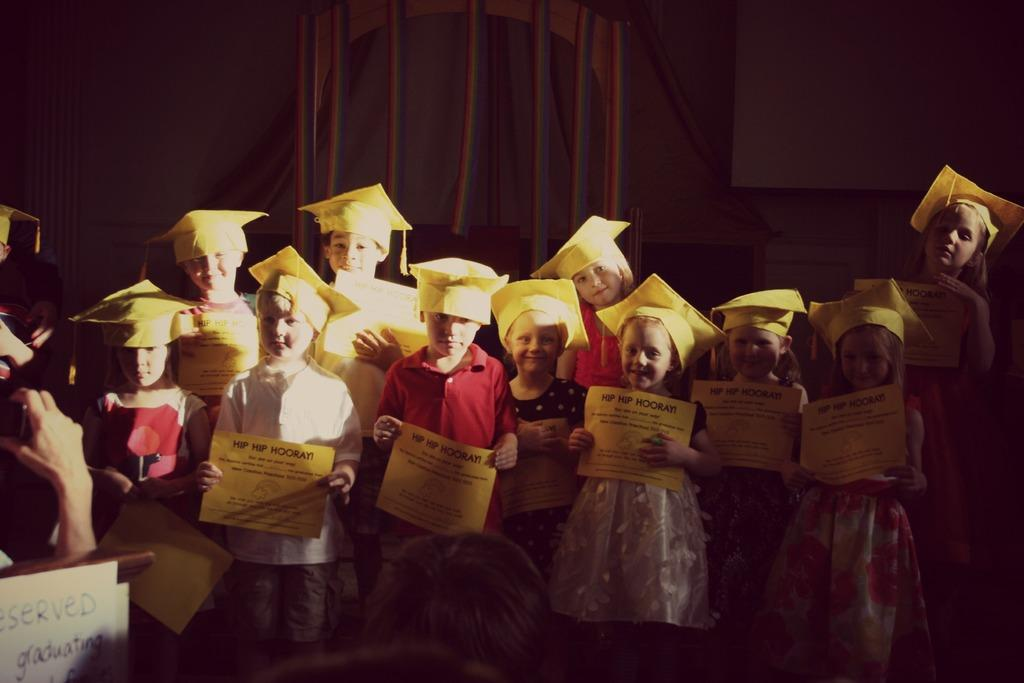What is the main subject of the image? The main subject of the image is a group of children. What are the children doing in the image? The children are standing and holding cards in their hands. What are the children wearing on their heads? The children are wearing yellow hats. What can be seen in the background of the image? There are curtains and a screen in the background of the image. What type of substance is being sprayed by the children in the image? There is no substance being sprayed by the children in the image; they are holding cards and wearing yellow hats. How many times do the children sneeze in the image? There is no sneezing depicted in the image; the children are holding cards and wearing yellow hats. 